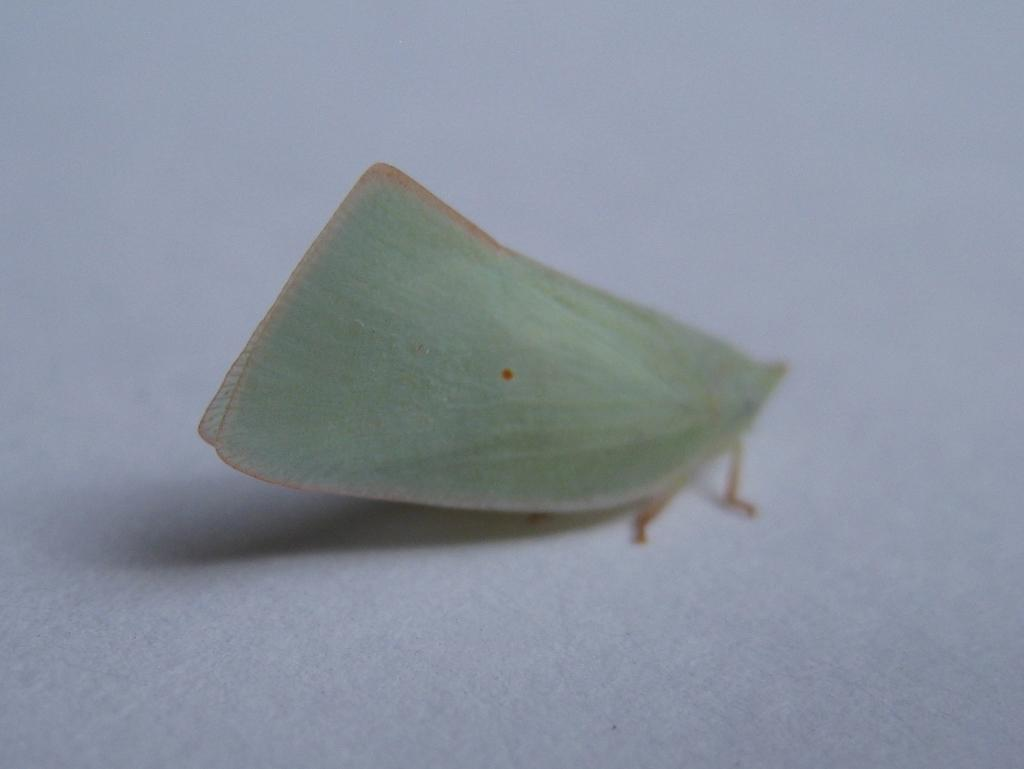What is the main subject of the picture? The main subject of the picture is a butterfly. What is the color of the surface the butterfly is on? The butterfly is on a white surface. What type of building can be seen in the background of the image? There is no building present in the image; it only features a butterfly on a white surface. What is the time of day depicted in the image? The time of day cannot be determined from the image, as it only features a butterfly on a white surface. 